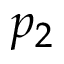<formula> <loc_0><loc_0><loc_500><loc_500>p _ { 2 }</formula> 